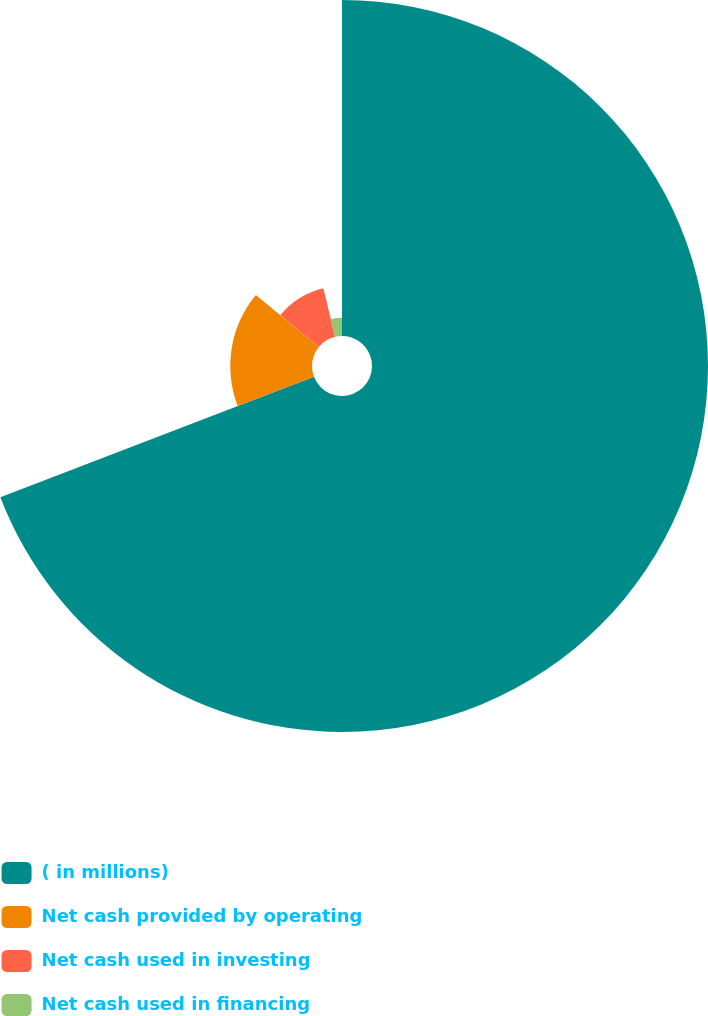Convert chart to OTSL. <chart><loc_0><loc_0><loc_500><loc_500><pie_chart><fcel>( in millions)<fcel>Net cash provided by operating<fcel>Net cash used in investing<fcel>Net cash used in financing<nl><fcel>69.16%<fcel>16.82%<fcel>10.28%<fcel>3.74%<nl></chart> 